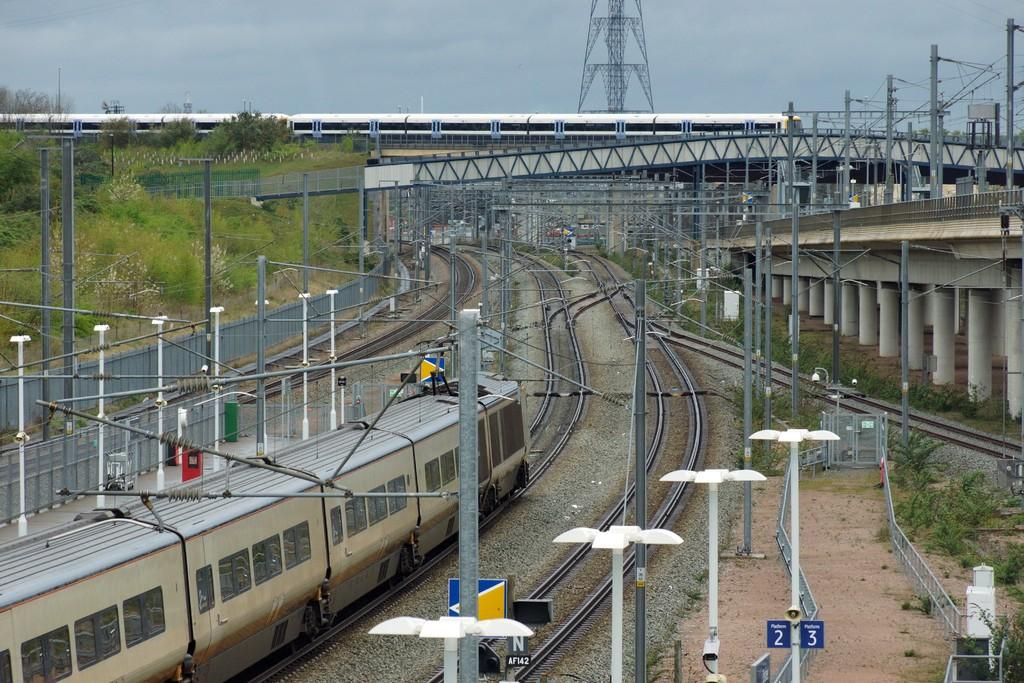<image>
Describe the image concisely. Train and landscape of a city with different tracks and street light posts that says 2 and 3. 